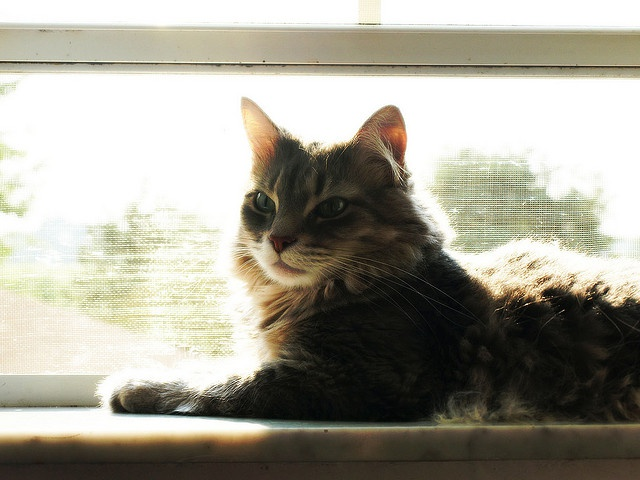Describe the objects in this image and their specific colors. I can see cat in white, black, ivory, gray, and tan tones and bench in white, black, and gray tones in this image. 